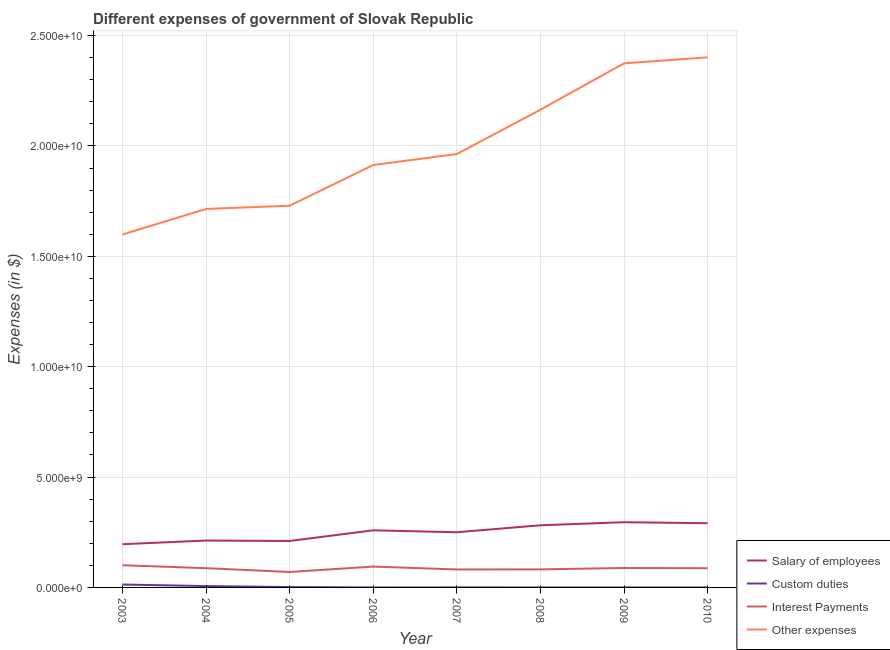How many different coloured lines are there?
Keep it short and to the point. 4. Does the line corresponding to amount spent on other expenses intersect with the line corresponding to amount spent on interest payments?
Make the answer very short. No. What is the amount spent on salary of employees in 2005?
Make the answer very short. 2.10e+09. Across all years, what is the maximum amount spent on salary of employees?
Provide a succinct answer. 2.96e+09. Across all years, what is the minimum amount spent on salary of employees?
Keep it short and to the point. 1.96e+09. In which year was the amount spent on interest payments maximum?
Your response must be concise. 2003. What is the total amount spent on interest payments in the graph?
Ensure brevity in your answer.  6.91e+09. What is the difference between the amount spent on custom duties in 2003 and that in 2010?
Keep it short and to the point. 1.31e+08. What is the difference between the amount spent on custom duties in 2006 and the amount spent on salary of employees in 2010?
Give a very brief answer. -2.91e+09. What is the average amount spent on interest payments per year?
Your response must be concise. 8.63e+08. In the year 2007, what is the difference between the amount spent on salary of employees and amount spent on other expenses?
Offer a terse response. -1.71e+1. What is the ratio of the amount spent on interest payments in 2005 to that in 2010?
Offer a terse response. 0.8. Is the amount spent on interest payments in 2004 less than that in 2006?
Keep it short and to the point. Yes. What is the difference between the highest and the second highest amount spent on custom duties?
Your answer should be very brief. 6.98e+07. What is the difference between the highest and the lowest amount spent on interest payments?
Offer a very short reply. 3.06e+08. In how many years, is the amount spent on other expenses greater than the average amount spent on other expenses taken over all years?
Offer a terse response. 3. Is it the case that in every year, the sum of the amount spent on other expenses and amount spent on salary of employees is greater than the sum of amount spent on custom duties and amount spent on interest payments?
Provide a short and direct response. Yes. Is it the case that in every year, the sum of the amount spent on salary of employees and amount spent on custom duties is greater than the amount spent on interest payments?
Provide a short and direct response. Yes. Is the amount spent on other expenses strictly greater than the amount spent on salary of employees over the years?
Your response must be concise. Yes. How many lines are there?
Offer a terse response. 4. How many years are there in the graph?
Offer a very short reply. 8. Are the values on the major ticks of Y-axis written in scientific E-notation?
Your response must be concise. Yes. Does the graph contain any zero values?
Offer a very short reply. Yes. Where does the legend appear in the graph?
Keep it short and to the point. Bottom right. How are the legend labels stacked?
Ensure brevity in your answer.  Vertical. What is the title of the graph?
Keep it short and to the point. Different expenses of government of Slovak Republic. Does "Denmark" appear as one of the legend labels in the graph?
Provide a short and direct response. No. What is the label or title of the X-axis?
Keep it short and to the point. Year. What is the label or title of the Y-axis?
Give a very brief answer. Expenses (in $). What is the Expenses (in $) of Salary of employees in 2003?
Your response must be concise. 1.96e+09. What is the Expenses (in $) of Custom duties in 2003?
Provide a short and direct response. 1.31e+08. What is the Expenses (in $) in Interest Payments in 2003?
Make the answer very short. 1.01e+09. What is the Expenses (in $) in Other expenses in 2003?
Provide a succinct answer. 1.60e+1. What is the Expenses (in $) of Salary of employees in 2004?
Offer a very short reply. 2.12e+09. What is the Expenses (in $) in Custom duties in 2004?
Ensure brevity in your answer.  6.16e+07. What is the Expenses (in $) in Interest Payments in 2004?
Ensure brevity in your answer.  8.73e+08. What is the Expenses (in $) in Other expenses in 2004?
Make the answer very short. 1.71e+1. What is the Expenses (in $) in Salary of employees in 2005?
Your answer should be compact. 2.10e+09. What is the Expenses (in $) of Custom duties in 2005?
Ensure brevity in your answer.  1.66e+07. What is the Expenses (in $) of Interest Payments in 2005?
Give a very brief answer. 7.00e+08. What is the Expenses (in $) of Other expenses in 2005?
Your answer should be compact. 1.73e+1. What is the Expenses (in $) in Salary of employees in 2006?
Your response must be concise. 2.59e+09. What is the Expenses (in $) of Custom duties in 2006?
Your response must be concise. 0. What is the Expenses (in $) in Interest Payments in 2006?
Keep it short and to the point. 9.45e+08. What is the Expenses (in $) of Other expenses in 2006?
Your response must be concise. 1.91e+1. What is the Expenses (in $) of Salary of employees in 2007?
Provide a succinct answer. 2.50e+09. What is the Expenses (in $) of Custom duties in 2007?
Your answer should be very brief. 7.16e+05. What is the Expenses (in $) of Interest Payments in 2007?
Your response must be concise. 8.14e+08. What is the Expenses (in $) in Other expenses in 2007?
Your answer should be very brief. 1.96e+1. What is the Expenses (in $) in Salary of employees in 2008?
Your answer should be very brief. 2.82e+09. What is the Expenses (in $) in Custom duties in 2008?
Your answer should be compact. 2.90e+04. What is the Expenses (in $) in Interest Payments in 2008?
Give a very brief answer. 8.18e+08. What is the Expenses (in $) of Other expenses in 2008?
Your answer should be very brief. 2.16e+1. What is the Expenses (in $) of Salary of employees in 2009?
Your answer should be compact. 2.96e+09. What is the Expenses (in $) in Custom duties in 2009?
Provide a succinct answer. 2.80e+04. What is the Expenses (in $) of Interest Payments in 2009?
Your answer should be very brief. 8.80e+08. What is the Expenses (in $) in Other expenses in 2009?
Your answer should be compact. 2.37e+1. What is the Expenses (in $) in Salary of employees in 2010?
Your answer should be compact. 2.91e+09. What is the Expenses (in $) in Custom duties in 2010?
Provide a succinct answer. 2.88e+04. What is the Expenses (in $) in Interest Payments in 2010?
Ensure brevity in your answer.  8.71e+08. What is the Expenses (in $) of Other expenses in 2010?
Give a very brief answer. 2.40e+1. Across all years, what is the maximum Expenses (in $) of Salary of employees?
Make the answer very short. 2.96e+09. Across all years, what is the maximum Expenses (in $) in Custom duties?
Offer a very short reply. 1.31e+08. Across all years, what is the maximum Expenses (in $) of Interest Payments?
Provide a short and direct response. 1.01e+09. Across all years, what is the maximum Expenses (in $) of Other expenses?
Your answer should be compact. 2.40e+1. Across all years, what is the minimum Expenses (in $) in Salary of employees?
Make the answer very short. 1.96e+09. Across all years, what is the minimum Expenses (in $) of Interest Payments?
Offer a terse response. 7.00e+08. Across all years, what is the minimum Expenses (in $) in Other expenses?
Provide a succinct answer. 1.60e+1. What is the total Expenses (in $) in Salary of employees in the graph?
Provide a succinct answer. 2.00e+1. What is the total Expenses (in $) of Custom duties in the graph?
Offer a very short reply. 2.10e+08. What is the total Expenses (in $) in Interest Payments in the graph?
Make the answer very short. 6.91e+09. What is the total Expenses (in $) in Other expenses in the graph?
Your answer should be very brief. 1.59e+11. What is the difference between the Expenses (in $) of Salary of employees in 2003 and that in 2004?
Provide a succinct answer. -1.66e+08. What is the difference between the Expenses (in $) of Custom duties in 2003 and that in 2004?
Offer a terse response. 6.98e+07. What is the difference between the Expenses (in $) of Interest Payments in 2003 and that in 2004?
Provide a succinct answer. 1.33e+08. What is the difference between the Expenses (in $) in Other expenses in 2003 and that in 2004?
Keep it short and to the point. -1.16e+09. What is the difference between the Expenses (in $) of Salary of employees in 2003 and that in 2005?
Your answer should be very brief. -1.46e+08. What is the difference between the Expenses (in $) of Custom duties in 2003 and that in 2005?
Your answer should be very brief. 1.15e+08. What is the difference between the Expenses (in $) in Interest Payments in 2003 and that in 2005?
Provide a short and direct response. 3.06e+08. What is the difference between the Expenses (in $) in Other expenses in 2003 and that in 2005?
Ensure brevity in your answer.  -1.31e+09. What is the difference between the Expenses (in $) of Salary of employees in 2003 and that in 2006?
Make the answer very short. -6.29e+08. What is the difference between the Expenses (in $) in Interest Payments in 2003 and that in 2006?
Ensure brevity in your answer.  6.08e+07. What is the difference between the Expenses (in $) in Other expenses in 2003 and that in 2006?
Your answer should be very brief. -3.15e+09. What is the difference between the Expenses (in $) in Salary of employees in 2003 and that in 2007?
Offer a terse response. -5.42e+08. What is the difference between the Expenses (in $) of Custom duties in 2003 and that in 2007?
Make the answer very short. 1.31e+08. What is the difference between the Expenses (in $) of Interest Payments in 2003 and that in 2007?
Give a very brief answer. 1.92e+08. What is the difference between the Expenses (in $) in Other expenses in 2003 and that in 2007?
Offer a very short reply. -3.65e+09. What is the difference between the Expenses (in $) in Salary of employees in 2003 and that in 2008?
Ensure brevity in your answer.  -8.58e+08. What is the difference between the Expenses (in $) in Custom duties in 2003 and that in 2008?
Offer a very short reply. 1.31e+08. What is the difference between the Expenses (in $) in Interest Payments in 2003 and that in 2008?
Your response must be concise. 1.88e+08. What is the difference between the Expenses (in $) in Other expenses in 2003 and that in 2008?
Provide a short and direct response. -5.65e+09. What is the difference between the Expenses (in $) of Salary of employees in 2003 and that in 2009?
Make the answer very short. -9.97e+08. What is the difference between the Expenses (in $) of Custom duties in 2003 and that in 2009?
Ensure brevity in your answer.  1.31e+08. What is the difference between the Expenses (in $) in Interest Payments in 2003 and that in 2009?
Make the answer very short. 1.26e+08. What is the difference between the Expenses (in $) in Other expenses in 2003 and that in 2009?
Provide a short and direct response. -7.75e+09. What is the difference between the Expenses (in $) in Salary of employees in 2003 and that in 2010?
Ensure brevity in your answer.  -9.51e+08. What is the difference between the Expenses (in $) in Custom duties in 2003 and that in 2010?
Provide a short and direct response. 1.31e+08. What is the difference between the Expenses (in $) of Interest Payments in 2003 and that in 2010?
Provide a short and direct response. 1.35e+08. What is the difference between the Expenses (in $) in Other expenses in 2003 and that in 2010?
Give a very brief answer. -8.03e+09. What is the difference between the Expenses (in $) in Salary of employees in 2004 and that in 2005?
Your answer should be very brief. 1.95e+07. What is the difference between the Expenses (in $) in Custom duties in 2004 and that in 2005?
Ensure brevity in your answer.  4.50e+07. What is the difference between the Expenses (in $) of Interest Payments in 2004 and that in 2005?
Make the answer very short. 1.73e+08. What is the difference between the Expenses (in $) in Other expenses in 2004 and that in 2005?
Give a very brief answer. -1.47e+08. What is the difference between the Expenses (in $) of Salary of employees in 2004 and that in 2006?
Ensure brevity in your answer.  -4.64e+08. What is the difference between the Expenses (in $) of Interest Payments in 2004 and that in 2006?
Provide a succinct answer. -7.22e+07. What is the difference between the Expenses (in $) of Other expenses in 2004 and that in 2006?
Offer a terse response. -1.99e+09. What is the difference between the Expenses (in $) in Salary of employees in 2004 and that in 2007?
Your answer should be compact. -3.76e+08. What is the difference between the Expenses (in $) of Custom duties in 2004 and that in 2007?
Provide a short and direct response. 6.09e+07. What is the difference between the Expenses (in $) of Interest Payments in 2004 and that in 2007?
Make the answer very short. 5.87e+07. What is the difference between the Expenses (in $) of Other expenses in 2004 and that in 2007?
Provide a short and direct response. -2.49e+09. What is the difference between the Expenses (in $) in Salary of employees in 2004 and that in 2008?
Your answer should be very brief. -6.92e+08. What is the difference between the Expenses (in $) in Custom duties in 2004 and that in 2008?
Give a very brief answer. 6.15e+07. What is the difference between the Expenses (in $) in Interest Payments in 2004 and that in 2008?
Provide a succinct answer. 5.47e+07. What is the difference between the Expenses (in $) in Other expenses in 2004 and that in 2008?
Offer a very short reply. -4.50e+09. What is the difference between the Expenses (in $) in Salary of employees in 2004 and that in 2009?
Make the answer very short. -8.31e+08. What is the difference between the Expenses (in $) of Custom duties in 2004 and that in 2009?
Offer a terse response. 6.15e+07. What is the difference between the Expenses (in $) in Interest Payments in 2004 and that in 2009?
Your answer should be compact. -7.40e+06. What is the difference between the Expenses (in $) of Other expenses in 2004 and that in 2009?
Offer a very short reply. -6.60e+09. What is the difference between the Expenses (in $) of Salary of employees in 2004 and that in 2010?
Offer a terse response. -7.85e+08. What is the difference between the Expenses (in $) of Custom duties in 2004 and that in 2010?
Your response must be concise. 6.15e+07. What is the difference between the Expenses (in $) in Interest Payments in 2004 and that in 2010?
Offer a terse response. 1.90e+06. What is the difference between the Expenses (in $) of Other expenses in 2004 and that in 2010?
Ensure brevity in your answer.  -6.87e+09. What is the difference between the Expenses (in $) in Salary of employees in 2005 and that in 2006?
Offer a very short reply. -4.83e+08. What is the difference between the Expenses (in $) in Interest Payments in 2005 and that in 2006?
Your response must be concise. -2.45e+08. What is the difference between the Expenses (in $) in Other expenses in 2005 and that in 2006?
Your answer should be compact. -1.84e+09. What is the difference between the Expenses (in $) of Salary of employees in 2005 and that in 2007?
Offer a terse response. -3.95e+08. What is the difference between the Expenses (in $) of Custom duties in 2005 and that in 2007?
Keep it short and to the point. 1.58e+07. What is the difference between the Expenses (in $) of Interest Payments in 2005 and that in 2007?
Offer a terse response. -1.14e+08. What is the difference between the Expenses (in $) in Other expenses in 2005 and that in 2007?
Ensure brevity in your answer.  -2.34e+09. What is the difference between the Expenses (in $) in Salary of employees in 2005 and that in 2008?
Give a very brief answer. -7.11e+08. What is the difference between the Expenses (in $) in Custom duties in 2005 and that in 2008?
Offer a terse response. 1.65e+07. What is the difference between the Expenses (in $) of Interest Payments in 2005 and that in 2008?
Keep it short and to the point. -1.18e+08. What is the difference between the Expenses (in $) of Other expenses in 2005 and that in 2008?
Make the answer very short. -4.35e+09. What is the difference between the Expenses (in $) in Salary of employees in 2005 and that in 2009?
Ensure brevity in your answer.  -8.51e+08. What is the difference between the Expenses (in $) in Custom duties in 2005 and that in 2009?
Give a very brief answer. 1.65e+07. What is the difference between the Expenses (in $) in Interest Payments in 2005 and that in 2009?
Your answer should be compact. -1.80e+08. What is the difference between the Expenses (in $) in Other expenses in 2005 and that in 2009?
Keep it short and to the point. -6.45e+09. What is the difference between the Expenses (in $) in Salary of employees in 2005 and that in 2010?
Your answer should be compact. -8.04e+08. What is the difference between the Expenses (in $) of Custom duties in 2005 and that in 2010?
Offer a terse response. 1.65e+07. What is the difference between the Expenses (in $) in Interest Payments in 2005 and that in 2010?
Provide a succinct answer. -1.71e+08. What is the difference between the Expenses (in $) in Other expenses in 2005 and that in 2010?
Make the answer very short. -6.72e+09. What is the difference between the Expenses (in $) of Salary of employees in 2006 and that in 2007?
Offer a terse response. 8.77e+07. What is the difference between the Expenses (in $) of Interest Payments in 2006 and that in 2007?
Your answer should be very brief. 1.31e+08. What is the difference between the Expenses (in $) in Other expenses in 2006 and that in 2007?
Keep it short and to the point. -4.96e+08. What is the difference between the Expenses (in $) of Salary of employees in 2006 and that in 2008?
Make the answer very short. -2.28e+08. What is the difference between the Expenses (in $) in Interest Payments in 2006 and that in 2008?
Give a very brief answer. 1.27e+08. What is the difference between the Expenses (in $) in Other expenses in 2006 and that in 2008?
Your response must be concise. -2.50e+09. What is the difference between the Expenses (in $) of Salary of employees in 2006 and that in 2009?
Make the answer very short. -3.68e+08. What is the difference between the Expenses (in $) in Interest Payments in 2006 and that in 2009?
Offer a terse response. 6.48e+07. What is the difference between the Expenses (in $) in Other expenses in 2006 and that in 2009?
Keep it short and to the point. -4.61e+09. What is the difference between the Expenses (in $) in Salary of employees in 2006 and that in 2010?
Provide a succinct answer. -3.21e+08. What is the difference between the Expenses (in $) of Interest Payments in 2006 and that in 2010?
Make the answer very short. 7.41e+07. What is the difference between the Expenses (in $) of Other expenses in 2006 and that in 2010?
Provide a succinct answer. -4.88e+09. What is the difference between the Expenses (in $) of Salary of employees in 2007 and that in 2008?
Offer a very short reply. -3.16e+08. What is the difference between the Expenses (in $) in Custom duties in 2007 and that in 2008?
Offer a very short reply. 6.87e+05. What is the difference between the Expenses (in $) in Interest Payments in 2007 and that in 2008?
Offer a very short reply. -4.01e+06. What is the difference between the Expenses (in $) in Other expenses in 2007 and that in 2008?
Your answer should be very brief. -2.01e+09. What is the difference between the Expenses (in $) in Salary of employees in 2007 and that in 2009?
Provide a succinct answer. -4.55e+08. What is the difference between the Expenses (in $) in Custom duties in 2007 and that in 2009?
Keep it short and to the point. 6.88e+05. What is the difference between the Expenses (in $) of Interest Payments in 2007 and that in 2009?
Give a very brief answer. -6.61e+07. What is the difference between the Expenses (in $) in Other expenses in 2007 and that in 2009?
Give a very brief answer. -4.11e+09. What is the difference between the Expenses (in $) in Salary of employees in 2007 and that in 2010?
Offer a very short reply. -4.09e+08. What is the difference between the Expenses (in $) in Custom duties in 2007 and that in 2010?
Ensure brevity in your answer.  6.87e+05. What is the difference between the Expenses (in $) of Interest Payments in 2007 and that in 2010?
Keep it short and to the point. -5.68e+07. What is the difference between the Expenses (in $) in Other expenses in 2007 and that in 2010?
Offer a very short reply. -4.38e+09. What is the difference between the Expenses (in $) of Salary of employees in 2008 and that in 2009?
Provide a succinct answer. -1.39e+08. What is the difference between the Expenses (in $) of Custom duties in 2008 and that in 2009?
Give a very brief answer. 996.89. What is the difference between the Expenses (in $) of Interest Payments in 2008 and that in 2009?
Make the answer very short. -6.21e+07. What is the difference between the Expenses (in $) in Other expenses in 2008 and that in 2009?
Your answer should be very brief. -2.10e+09. What is the difference between the Expenses (in $) in Salary of employees in 2008 and that in 2010?
Keep it short and to the point. -9.27e+07. What is the difference between the Expenses (in $) in Custom duties in 2008 and that in 2010?
Offer a very short reply. 207.07. What is the difference between the Expenses (in $) in Interest Payments in 2008 and that in 2010?
Offer a terse response. -5.28e+07. What is the difference between the Expenses (in $) in Other expenses in 2008 and that in 2010?
Ensure brevity in your answer.  -2.37e+09. What is the difference between the Expenses (in $) of Salary of employees in 2009 and that in 2010?
Keep it short and to the point. 4.65e+07. What is the difference between the Expenses (in $) of Custom duties in 2009 and that in 2010?
Provide a short and direct response. -789.82. What is the difference between the Expenses (in $) in Interest Payments in 2009 and that in 2010?
Your answer should be compact. 9.30e+06. What is the difference between the Expenses (in $) of Other expenses in 2009 and that in 2010?
Keep it short and to the point. -2.73e+08. What is the difference between the Expenses (in $) in Salary of employees in 2003 and the Expenses (in $) in Custom duties in 2004?
Offer a terse response. 1.90e+09. What is the difference between the Expenses (in $) of Salary of employees in 2003 and the Expenses (in $) of Interest Payments in 2004?
Your answer should be compact. 1.09e+09. What is the difference between the Expenses (in $) of Salary of employees in 2003 and the Expenses (in $) of Other expenses in 2004?
Your response must be concise. -1.52e+1. What is the difference between the Expenses (in $) of Custom duties in 2003 and the Expenses (in $) of Interest Payments in 2004?
Make the answer very short. -7.41e+08. What is the difference between the Expenses (in $) in Custom duties in 2003 and the Expenses (in $) in Other expenses in 2004?
Your answer should be very brief. -1.70e+1. What is the difference between the Expenses (in $) of Interest Payments in 2003 and the Expenses (in $) of Other expenses in 2004?
Your answer should be compact. -1.61e+1. What is the difference between the Expenses (in $) of Salary of employees in 2003 and the Expenses (in $) of Custom duties in 2005?
Ensure brevity in your answer.  1.94e+09. What is the difference between the Expenses (in $) in Salary of employees in 2003 and the Expenses (in $) in Interest Payments in 2005?
Offer a terse response. 1.26e+09. What is the difference between the Expenses (in $) in Salary of employees in 2003 and the Expenses (in $) in Other expenses in 2005?
Provide a short and direct response. -1.53e+1. What is the difference between the Expenses (in $) in Custom duties in 2003 and the Expenses (in $) in Interest Payments in 2005?
Make the answer very short. -5.69e+08. What is the difference between the Expenses (in $) of Custom duties in 2003 and the Expenses (in $) of Other expenses in 2005?
Offer a very short reply. -1.72e+1. What is the difference between the Expenses (in $) in Interest Payments in 2003 and the Expenses (in $) in Other expenses in 2005?
Offer a terse response. -1.63e+1. What is the difference between the Expenses (in $) in Salary of employees in 2003 and the Expenses (in $) in Interest Payments in 2006?
Offer a very short reply. 1.01e+09. What is the difference between the Expenses (in $) of Salary of employees in 2003 and the Expenses (in $) of Other expenses in 2006?
Keep it short and to the point. -1.72e+1. What is the difference between the Expenses (in $) in Custom duties in 2003 and the Expenses (in $) in Interest Payments in 2006?
Your answer should be very brief. -8.13e+08. What is the difference between the Expenses (in $) in Custom duties in 2003 and the Expenses (in $) in Other expenses in 2006?
Your response must be concise. -1.90e+1. What is the difference between the Expenses (in $) in Interest Payments in 2003 and the Expenses (in $) in Other expenses in 2006?
Your answer should be very brief. -1.81e+1. What is the difference between the Expenses (in $) of Salary of employees in 2003 and the Expenses (in $) of Custom duties in 2007?
Keep it short and to the point. 1.96e+09. What is the difference between the Expenses (in $) of Salary of employees in 2003 and the Expenses (in $) of Interest Payments in 2007?
Offer a very short reply. 1.14e+09. What is the difference between the Expenses (in $) in Salary of employees in 2003 and the Expenses (in $) in Other expenses in 2007?
Your answer should be very brief. -1.77e+1. What is the difference between the Expenses (in $) of Custom duties in 2003 and the Expenses (in $) of Interest Payments in 2007?
Your answer should be very brief. -6.83e+08. What is the difference between the Expenses (in $) in Custom duties in 2003 and the Expenses (in $) in Other expenses in 2007?
Keep it short and to the point. -1.95e+1. What is the difference between the Expenses (in $) of Interest Payments in 2003 and the Expenses (in $) of Other expenses in 2007?
Provide a short and direct response. -1.86e+1. What is the difference between the Expenses (in $) in Salary of employees in 2003 and the Expenses (in $) in Custom duties in 2008?
Your response must be concise. 1.96e+09. What is the difference between the Expenses (in $) in Salary of employees in 2003 and the Expenses (in $) in Interest Payments in 2008?
Keep it short and to the point. 1.14e+09. What is the difference between the Expenses (in $) in Salary of employees in 2003 and the Expenses (in $) in Other expenses in 2008?
Make the answer very short. -1.97e+1. What is the difference between the Expenses (in $) in Custom duties in 2003 and the Expenses (in $) in Interest Payments in 2008?
Provide a short and direct response. -6.87e+08. What is the difference between the Expenses (in $) of Custom duties in 2003 and the Expenses (in $) of Other expenses in 2008?
Provide a succinct answer. -2.15e+1. What is the difference between the Expenses (in $) in Interest Payments in 2003 and the Expenses (in $) in Other expenses in 2008?
Keep it short and to the point. -2.06e+1. What is the difference between the Expenses (in $) of Salary of employees in 2003 and the Expenses (in $) of Custom duties in 2009?
Your response must be concise. 1.96e+09. What is the difference between the Expenses (in $) in Salary of employees in 2003 and the Expenses (in $) in Interest Payments in 2009?
Make the answer very short. 1.08e+09. What is the difference between the Expenses (in $) in Salary of employees in 2003 and the Expenses (in $) in Other expenses in 2009?
Keep it short and to the point. -2.18e+1. What is the difference between the Expenses (in $) in Custom duties in 2003 and the Expenses (in $) in Interest Payments in 2009?
Offer a very short reply. -7.49e+08. What is the difference between the Expenses (in $) of Custom duties in 2003 and the Expenses (in $) of Other expenses in 2009?
Ensure brevity in your answer.  -2.36e+1. What is the difference between the Expenses (in $) of Interest Payments in 2003 and the Expenses (in $) of Other expenses in 2009?
Make the answer very short. -2.27e+1. What is the difference between the Expenses (in $) of Salary of employees in 2003 and the Expenses (in $) of Custom duties in 2010?
Provide a short and direct response. 1.96e+09. What is the difference between the Expenses (in $) of Salary of employees in 2003 and the Expenses (in $) of Interest Payments in 2010?
Your answer should be very brief. 1.09e+09. What is the difference between the Expenses (in $) of Salary of employees in 2003 and the Expenses (in $) of Other expenses in 2010?
Offer a very short reply. -2.21e+1. What is the difference between the Expenses (in $) of Custom duties in 2003 and the Expenses (in $) of Interest Payments in 2010?
Offer a very short reply. -7.39e+08. What is the difference between the Expenses (in $) of Custom duties in 2003 and the Expenses (in $) of Other expenses in 2010?
Your answer should be compact. -2.39e+1. What is the difference between the Expenses (in $) of Interest Payments in 2003 and the Expenses (in $) of Other expenses in 2010?
Keep it short and to the point. -2.30e+1. What is the difference between the Expenses (in $) in Salary of employees in 2004 and the Expenses (in $) in Custom duties in 2005?
Keep it short and to the point. 2.11e+09. What is the difference between the Expenses (in $) in Salary of employees in 2004 and the Expenses (in $) in Interest Payments in 2005?
Offer a terse response. 1.42e+09. What is the difference between the Expenses (in $) in Salary of employees in 2004 and the Expenses (in $) in Other expenses in 2005?
Provide a succinct answer. -1.52e+1. What is the difference between the Expenses (in $) of Custom duties in 2004 and the Expenses (in $) of Interest Payments in 2005?
Offer a terse response. -6.38e+08. What is the difference between the Expenses (in $) in Custom duties in 2004 and the Expenses (in $) in Other expenses in 2005?
Keep it short and to the point. -1.72e+1. What is the difference between the Expenses (in $) in Interest Payments in 2004 and the Expenses (in $) in Other expenses in 2005?
Your answer should be very brief. -1.64e+1. What is the difference between the Expenses (in $) of Salary of employees in 2004 and the Expenses (in $) of Interest Payments in 2006?
Provide a short and direct response. 1.18e+09. What is the difference between the Expenses (in $) in Salary of employees in 2004 and the Expenses (in $) in Other expenses in 2006?
Give a very brief answer. -1.70e+1. What is the difference between the Expenses (in $) in Custom duties in 2004 and the Expenses (in $) in Interest Payments in 2006?
Provide a short and direct response. -8.83e+08. What is the difference between the Expenses (in $) in Custom duties in 2004 and the Expenses (in $) in Other expenses in 2006?
Offer a terse response. -1.91e+1. What is the difference between the Expenses (in $) in Interest Payments in 2004 and the Expenses (in $) in Other expenses in 2006?
Provide a succinct answer. -1.83e+1. What is the difference between the Expenses (in $) in Salary of employees in 2004 and the Expenses (in $) in Custom duties in 2007?
Your answer should be very brief. 2.12e+09. What is the difference between the Expenses (in $) of Salary of employees in 2004 and the Expenses (in $) of Interest Payments in 2007?
Offer a very short reply. 1.31e+09. What is the difference between the Expenses (in $) of Salary of employees in 2004 and the Expenses (in $) of Other expenses in 2007?
Ensure brevity in your answer.  -1.75e+1. What is the difference between the Expenses (in $) of Custom duties in 2004 and the Expenses (in $) of Interest Payments in 2007?
Keep it short and to the point. -7.52e+08. What is the difference between the Expenses (in $) in Custom duties in 2004 and the Expenses (in $) in Other expenses in 2007?
Offer a very short reply. -1.96e+1. What is the difference between the Expenses (in $) in Interest Payments in 2004 and the Expenses (in $) in Other expenses in 2007?
Your response must be concise. -1.88e+1. What is the difference between the Expenses (in $) in Salary of employees in 2004 and the Expenses (in $) in Custom duties in 2008?
Offer a very short reply. 2.12e+09. What is the difference between the Expenses (in $) in Salary of employees in 2004 and the Expenses (in $) in Interest Payments in 2008?
Provide a short and direct response. 1.31e+09. What is the difference between the Expenses (in $) of Salary of employees in 2004 and the Expenses (in $) of Other expenses in 2008?
Give a very brief answer. -1.95e+1. What is the difference between the Expenses (in $) of Custom duties in 2004 and the Expenses (in $) of Interest Payments in 2008?
Your response must be concise. -7.56e+08. What is the difference between the Expenses (in $) of Custom duties in 2004 and the Expenses (in $) of Other expenses in 2008?
Offer a very short reply. -2.16e+1. What is the difference between the Expenses (in $) in Interest Payments in 2004 and the Expenses (in $) in Other expenses in 2008?
Offer a terse response. -2.08e+1. What is the difference between the Expenses (in $) of Salary of employees in 2004 and the Expenses (in $) of Custom duties in 2009?
Provide a short and direct response. 2.12e+09. What is the difference between the Expenses (in $) of Salary of employees in 2004 and the Expenses (in $) of Interest Payments in 2009?
Your answer should be compact. 1.24e+09. What is the difference between the Expenses (in $) of Salary of employees in 2004 and the Expenses (in $) of Other expenses in 2009?
Your response must be concise. -2.16e+1. What is the difference between the Expenses (in $) of Custom duties in 2004 and the Expenses (in $) of Interest Payments in 2009?
Your answer should be very brief. -8.18e+08. What is the difference between the Expenses (in $) of Custom duties in 2004 and the Expenses (in $) of Other expenses in 2009?
Give a very brief answer. -2.37e+1. What is the difference between the Expenses (in $) in Interest Payments in 2004 and the Expenses (in $) in Other expenses in 2009?
Provide a short and direct response. -2.29e+1. What is the difference between the Expenses (in $) of Salary of employees in 2004 and the Expenses (in $) of Custom duties in 2010?
Offer a terse response. 2.12e+09. What is the difference between the Expenses (in $) of Salary of employees in 2004 and the Expenses (in $) of Interest Payments in 2010?
Provide a short and direct response. 1.25e+09. What is the difference between the Expenses (in $) of Salary of employees in 2004 and the Expenses (in $) of Other expenses in 2010?
Your response must be concise. -2.19e+1. What is the difference between the Expenses (in $) of Custom duties in 2004 and the Expenses (in $) of Interest Payments in 2010?
Your answer should be very brief. -8.09e+08. What is the difference between the Expenses (in $) of Custom duties in 2004 and the Expenses (in $) of Other expenses in 2010?
Make the answer very short. -2.40e+1. What is the difference between the Expenses (in $) of Interest Payments in 2004 and the Expenses (in $) of Other expenses in 2010?
Offer a very short reply. -2.31e+1. What is the difference between the Expenses (in $) in Salary of employees in 2005 and the Expenses (in $) in Interest Payments in 2006?
Ensure brevity in your answer.  1.16e+09. What is the difference between the Expenses (in $) of Salary of employees in 2005 and the Expenses (in $) of Other expenses in 2006?
Your response must be concise. -1.70e+1. What is the difference between the Expenses (in $) of Custom duties in 2005 and the Expenses (in $) of Interest Payments in 2006?
Your answer should be very brief. -9.28e+08. What is the difference between the Expenses (in $) in Custom duties in 2005 and the Expenses (in $) in Other expenses in 2006?
Make the answer very short. -1.91e+1. What is the difference between the Expenses (in $) in Interest Payments in 2005 and the Expenses (in $) in Other expenses in 2006?
Ensure brevity in your answer.  -1.84e+1. What is the difference between the Expenses (in $) of Salary of employees in 2005 and the Expenses (in $) of Custom duties in 2007?
Provide a succinct answer. 2.10e+09. What is the difference between the Expenses (in $) in Salary of employees in 2005 and the Expenses (in $) in Interest Payments in 2007?
Offer a very short reply. 1.29e+09. What is the difference between the Expenses (in $) in Salary of employees in 2005 and the Expenses (in $) in Other expenses in 2007?
Your answer should be compact. -1.75e+1. What is the difference between the Expenses (in $) of Custom duties in 2005 and the Expenses (in $) of Interest Payments in 2007?
Keep it short and to the point. -7.97e+08. What is the difference between the Expenses (in $) in Custom duties in 2005 and the Expenses (in $) in Other expenses in 2007?
Ensure brevity in your answer.  -1.96e+1. What is the difference between the Expenses (in $) in Interest Payments in 2005 and the Expenses (in $) in Other expenses in 2007?
Your answer should be very brief. -1.89e+1. What is the difference between the Expenses (in $) of Salary of employees in 2005 and the Expenses (in $) of Custom duties in 2008?
Keep it short and to the point. 2.10e+09. What is the difference between the Expenses (in $) in Salary of employees in 2005 and the Expenses (in $) in Interest Payments in 2008?
Your answer should be very brief. 1.29e+09. What is the difference between the Expenses (in $) in Salary of employees in 2005 and the Expenses (in $) in Other expenses in 2008?
Offer a terse response. -1.95e+1. What is the difference between the Expenses (in $) of Custom duties in 2005 and the Expenses (in $) of Interest Payments in 2008?
Make the answer very short. -8.01e+08. What is the difference between the Expenses (in $) in Custom duties in 2005 and the Expenses (in $) in Other expenses in 2008?
Your answer should be very brief. -2.16e+1. What is the difference between the Expenses (in $) in Interest Payments in 2005 and the Expenses (in $) in Other expenses in 2008?
Ensure brevity in your answer.  -2.09e+1. What is the difference between the Expenses (in $) in Salary of employees in 2005 and the Expenses (in $) in Custom duties in 2009?
Offer a terse response. 2.10e+09. What is the difference between the Expenses (in $) of Salary of employees in 2005 and the Expenses (in $) of Interest Payments in 2009?
Keep it short and to the point. 1.22e+09. What is the difference between the Expenses (in $) of Salary of employees in 2005 and the Expenses (in $) of Other expenses in 2009?
Give a very brief answer. -2.16e+1. What is the difference between the Expenses (in $) of Custom duties in 2005 and the Expenses (in $) of Interest Payments in 2009?
Give a very brief answer. -8.64e+08. What is the difference between the Expenses (in $) in Custom duties in 2005 and the Expenses (in $) in Other expenses in 2009?
Provide a succinct answer. -2.37e+1. What is the difference between the Expenses (in $) in Interest Payments in 2005 and the Expenses (in $) in Other expenses in 2009?
Your answer should be compact. -2.30e+1. What is the difference between the Expenses (in $) of Salary of employees in 2005 and the Expenses (in $) of Custom duties in 2010?
Provide a short and direct response. 2.10e+09. What is the difference between the Expenses (in $) of Salary of employees in 2005 and the Expenses (in $) of Interest Payments in 2010?
Your answer should be compact. 1.23e+09. What is the difference between the Expenses (in $) of Salary of employees in 2005 and the Expenses (in $) of Other expenses in 2010?
Provide a succinct answer. -2.19e+1. What is the difference between the Expenses (in $) of Custom duties in 2005 and the Expenses (in $) of Interest Payments in 2010?
Keep it short and to the point. -8.54e+08. What is the difference between the Expenses (in $) in Custom duties in 2005 and the Expenses (in $) in Other expenses in 2010?
Your response must be concise. -2.40e+1. What is the difference between the Expenses (in $) of Interest Payments in 2005 and the Expenses (in $) of Other expenses in 2010?
Offer a very short reply. -2.33e+1. What is the difference between the Expenses (in $) of Salary of employees in 2006 and the Expenses (in $) of Custom duties in 2007?
Make the answer very short. 2.59e+09. What is the difference between the Expenses (in $) of Salary of employees in 2006 and the Expenses (in $) of Interest Payments in 2007?
Your answer should be compact. 1.77e+09. What is the difference between the Expenses (in $) of Salary of employees in 2006 and the Expenses (in $) of Other expenses in 2007?
Ensure brevity in your answer.  -1.70e+1. What is the difference between the Expenses (in $) of Interest Payments in 2006 and the Expenses (in $) of Other expenses in 2007?
Make the answer very short. -1.87e+1. What is the difference between the Expenses (in $) in Salary of employees in 2006 and the Expenses (in $) in Custom duties in 2008?
Your response must be concise. 2.59e+09. What is the difference between the Expenses (in $) of Salary of employees in 2006 and the Expenses (in $) of Interest Payments in 2008?
Your response must be concise. 1.77e+09. What is the difference between the Expenses (in $) of Salary of employees in 2006 and the Expenses (in $) of Other expenses in 2008?
Offer a very short reply. -1.91e+1. What is the difference between the Expenses (in $) in Interest Payments in 2006 and the Expenses (in $) in Other expenses in 2008?
Your answer should be very brief. -2.07e+1. What is the difference between the Expenses (in $) in Salary of employees in 2006 and the Expenses (in $) in Custom duties in 2009?
Ensure brevity in your answer.  2.59e+09. What is the difference between the Expenses (in $) in Salary of employees in 2006 and the Expenses (in $) in Interest Payments in 2009?
Your answer should be compact. 1.71e+09. What is the difference between the Expenses (in $) in Salary of employees in 2006 and the Expenses (in $) in Other expenses in 2009?
Your answer should be very brief. -2.12e+1. What is the difference between the Expenses (in $) in Interest Payments in 2006 and the Expenses (in $) in Other expenses in 2009?
Make the answer very short. -2.28e+1. What is the difference between the Expenses (in $) in Salary of employees in 2006 and the Expenses (in $) in Custom duties in 2010?
Keep it short and to the point. 2.59e+09. What is the difference between the Expenses (in $) in Salary of employees in 2006 and the Expenses (in $) in Interest Payments in 2010?
Ensure brevity in your answer.  1.72e+09. What is the difference between the Expenses (in $) in Salary of employees in 2006 and the Expenses (in $) in Other expenses in 2010?
Make the answer very short. -2.14e+1. What is the difference between the Expenses (in $) of Interest Payments in 2006 and the Expenses (in $) of Other expenses in 2010?
Ensure brevity in your answer.  -2.31e+1. What is the difference between the Expenses (in $) in Salary of employees in 2007 and the Expenses (in $) in Custom duties in 2008?
Your response must be concise. 2.50e+09. What is the difference between the Expenses (in $) of Salary of employees in 2007 and the Expenses (in $) of Interest Payments in 2008?
Give a very brief answer. 1.68e+09. What is the difference between the Expenses (in $) in Salary of employees in 2007 and the Expenses (in $) in Other expenses in 2008?
Ensure brevity in your answer.  -1.91e+1. What is the difference between the Expenses (in $) of Custom duties in 2007 and the Expenses (in $) of Interest Payments in 2008?
Give a very brief answer. -8.17e+08. What is the difference between the Expenses (in $) in Custom duties in 2007 and the Expenses (in $) in Other expenses in 2008?
Your response must be concise. -2.16e+1. What is the difference between the Expenses (in $) of Interest Payments in 2007 and the Expenses (in $) of Other expenses in 2008?
Provide a succinct answer. -2.08e+1. What is the difference between the Expenses (in $) in Salary of employees in 2007 and the Expenses (in $) in Custom duties in 2009?
Ensure brevity in your answer.  2.50e+09. What is the difference between the Expenses (in $) in Salary of employees in 2007 and the Expenses (in $) in Interest Payments in 2009?
Offer a terse response. 1.62e+09. What is the difference between the Expenses (in $) of Salary of employees in 2007 and the Expenses (in $) of Other expenses in 2009?
Provide a short and direct response. -2.12e+1. What is the difference between the Expenses (in $) in Custom duties in 2007 and the Expenses (in $) in Interest Payments in 2009?
Offer a terse response. -8.79e+08. What is the difference between the Expenses (in $) of Custom duties in 2007 and the Expenses (in $) of Other expenses in 2009?
Give a very brief answer. -2.37e+1. What is the difference between the Expenses (in $) in Interest Payments in 2007 and the Expenses (in $) in Other expenses in 2009?
Offer a terse response. -2.29e+1. What is the difference between the Expenses (in $) in Salary of employees in 2007 and the Expenses (in $) in Custom duties in 2010?
Your response must be concise. 2.50e+09. What is the difference between the Expenses (in $) of Salary of employees in 2007 and the Expenses (in $) of Interest Payments in 2010?
Keep it short and to the point. 1.63e+09. What is the difference between the Expenses (in $) in Salary of employees in 2007 and the Expenses (in $) in Other expenses in 2010?
Your answer should be very brief. -2.15e+1. What is the difference between the Expenses (in $) in Custom duties in 2007 and the Expenses (in $) in Interest Payments in 2010?
Make the answer very short. -8.70e+08. What is the difference between the Expenses (in $) of Custom duties in 2007 and the Expenses (in $) of Other expenses in 2010?
Provide a succinct answer. -2.40e+1. What is the difference between the Expenses (in $) of Interest Payments in 2007 and the Expenses (in $) of Other expenses in 2010?
Make the answer very short. -2.32e+1. What is the difference between the Expenses (in $) of Salary of employees in 2008 and the Expenses (in $) of Custom duties in 2009?
Provide a succinct answer. 2.82e+09. What is the difference between the Expenses (in $) of Salary of employees in 2008 and the Expenses (in $) of Interest Payments in 2009?
Provide a short and direct response. 1.94e+09. What is the difference between the Expenses (in $) in Salary of employees in 2008 and the Expenses (in $) in Other expenses in 2009?
Keep it short and to the point. -2.09e+1. What is the difference between the Expenses (in $) of Custom duties in 2008 and the Expenses (in $) of Interest Payments in 2009?
Your response must be concise. -8.80e+08. What is the difference between the Expenses (in $) of Custom duties in 2008 and the Expenses (in $) of Other expenses in 2009?
Keep it short and to the point. -2.37e+1. What is the difference between the Expenses (in $) of Interest Payments in 2008 and the Expenses (in $) of Other expenses in 2009?
Give a very brief answer. -2.29e+1. What is the difference between the Expenses (in $) in Salary of employees in 2008 and the Expenses (in $) in Custom duties in 2010?
Ensure brevity in your answer.  2.82e+09. What is the difference between the Expenses (in $) of Salary of employees in 2008 and the Expenses (in $) of Interest Payments in 2010?
Offer a terse response. 1.95e+09. What is the difference between the Expenses (in $) of Salary of employees in 2008 and the Expenses (in $) of Other expenses in 2010?
Provide a succinct answer. -2.12e+1. What is the difference between the Expenses (in $) of Custom duties in 2008 and the Expenses (in $) of Interest Payments in 2010?
Give a very brief answer. -8.71e+08. What is the difference between the Expenses (in $) in Custom duties in 2008 and the Expenses (in $) in Other expenses in 2010?
Keep it short and to the point. -2.40e+1. What is the difference between the Expenses (in $) in Interest Payments in 2008 and the Expenses (in $) in Other expenses in 2010?
Your answer should be very brief. -2.32e+1. What is the difference between the Expenses (in $) in Salary of employees in 2009 and the Expenses (in $) in Custom duties in 2010?
Provide a succinct answer. 2.96e+09. What is the difference between the Expenses (in $) of Salary of employees in 2009 and the Expenses (in $) of Interest Payments in 2010?
Keep it short and to the point. 2.08e+09. What is the difference between the Expenses (in $) of Salary of employees in 2009 and the Expenses (in $) of Other expenses in 2010?
Make the answer very short. -2.11e+1. What is the difference between the Expenses (in $) in Custom duties in 2009 and the Expenses (in $) in Interest Payments in 2010?
Your response must be concise. -8.71e+08. What is the difference between the Expenses (in $) in Custom duties in 2009 and the Expenses (in $) in Other expenses in 2010?
Your answer should be very brief. -2.40e+1. What is the difference between the Expenses (in $) in Interest Payments in 2009 and the Expenses (in $) in Other expenses in 2010?
Keep it short and to the point. -2.31e+1. What is the average Expenses (in $) of Salary of employees per year?
Make the answer very short. 2.49e+09. What is the average Expenses (in $) of Custom duties per year?
Your response must be concise. 2.63e+07. What is the average Expenses (in $) of Interest Payments per year?
Make the answer very short. 8.63e+08. What is the average Expenses (in $) in Other expenses per year?
Offer a terse response. 1.98e+1. In the year 2003, what is the difference between the Expenses (in $) of Salary of employees and Expenses (in $) of Custom duties?
Your answer should be compact. 1.83e+09. In the year 2003, what is the difference between the Expenses (in $) of Salary of employees and Expenses (in $) of Interest Payments?
Make the answer very short. 9.52e+08. In the year 2003, what is the difference between the Expenses (in $) of Salary of employees and Expenses (in $) of Other expenses?
Your answer should be compact. -1.40e+1. In the year 2003, what is the difference between the Expenses (in $) of Custom duties and Expenses (in $) of Interest Payments?
Ensure brevity in your answer.  -8.74e+08. In the year 2003, what is the difference between the Expenses (in $) in Custom duties and Expenses (in $) in Other expenses?
Provide a short and direct response. -1.59e+1. In the year 2003, what is the difference between the Expenses (in $) in Interest Payments and Expenses (in $) in Other expenses?
Give a very brief answer. -1.50e+1. In the year 2004, what is the difference between the Expenses (in $) in Salary of employees and Expenses (in $) in Custom duties?
Your answer should be compact. 2.06e+09. In the year 2004, what is the difference between the Expenses (in $) in Salary of employees and Expenses (in $) in Interest Payments?
Provide a short and direct response. 1.25e+09. In the year 2004, what is the difference between the Expenses (in $) of Salary of employees and Expenses (in $) of Other expenses?
Keep it short and to the point. -1.50e+1. In the year 2004, what is the difference between the Expenses (in $) of Custom duties and Expenses (in $) of Interest Payments?
Your response must be concise. -8.11e+08. In the year 2004, what is the difference between the Expenses (in $) in Custom duties and Expenses (in $) in Other expenses?
Keep it short and to the point. -1.71e+1. In the year 2004, what is the difference between the Expenses (in $) of Interest Payments and Expenses (in $) of Other expenses?
Your response must be concise. -1.63e+1. In the year 2005, what is the difference between the Expenses (in $) in Salary of employees and Expenses (in $) in Custom duties?
Offer a very short reply. 2.09e+09. In the year 2005, what is the difference between the Expenses (in $) in Salary of employees and Expenses (in $) in Interest Payments?
Offer a very short reply. 1.40e+09. In the year 2005, what is the difference between the Expenses (in $) in Salary of employees and Expenses (in $) in Other expenses?
Offer a very short reply. -1.52e+1. In the year 2005, what is the difference between the Expenses (in $) in Custom duties and Expenses (in $) in Interest Payments?
Your response must be concise. -6.83e+08. In the year 2005, what is the difference between the Expenses (in $) in Custom duties and Expenses (in $) in Other expenses?
Your response must be concise. -1.73e+1. In the year 2005, what is the difference between the Expenses (in $) in Interest Payments and Expenses (in $) in Other expenses?
Your answer should be very brief. -1.66e+1. In the year 2006, what is the difference between the Expenses (in $) of Salary of employees and Expenses (in $) of Interest Payments?
Provide a succinct answer. 1.64e+09. In the year 2006, what is the difference between the Expenses (in $) in Salary of employees and Expenses (in $) in Other expenses?
Give a very brief answer. -1.66e+1. In the year 2006, what is the difference between the Expenses (in $) of Interest Payments and Expenses (in $) of Other expenses?
Your answer should be compact. -1.82e+1. In the year 2007, what is the difference between the Expenses (in $) of Salary of employees and Expenses (in $) of Custom duties?
Offer a very short reply. 2.50e+09. In the year 2007, what is the difference between the Expenses (in $) in Salary of employees and Expenses (in $) in Interest Payments?
Keep it short and to the point. 1.69e+09. In the year 2007, what is the difference between the Expenses (in $) of Salary of employees and Expenses (in $) of Other expenses?
Make the answer very short. -1.71e+1. In the year 2007, what is the difference between the Expenses (in $) in Custom duties and Expenses (in $) in Interest Payments?
Give a very brief answer. -8.13e+08. In the year 2007, what is the difference between the Expenses (in $) of Custom duties and Expenses (in $) of Other expenses?
Offer a terse response. -1.96e+1. In the year 2007, what is the difference between the Expenses (in $) of Interest Payments and Expenses (in $) of Other expenses?
Give a very brief answer. -1.88e+1. In the year 2008, what is the difference between the Expenses (in $) in Salary of employees and Expenses (in $) in Custom duties?
Your response must be concise. 2.82e+09. In the year 2008, what is the difference between the Expenses (in $) in Salary of employees and Expenses (in $) in Interest Payments?
Provide a succinct answer. 2.00e+09. In the year 2008, what is the difference between the Expenses (in $) of Salary of employees and Expenses (in $) of Other expenses?
Your response must be concise. -1.88e+1. In the year 2008, what is the difference between the Expenses (in $) in Custom duties and Expenses (in $) in Interest Payments?
Make the answer very short. -8.18e+08. In the year 2008, what is the difference between the Expenses (in $) of Custom duties and Expenses (in $) of Other expenses?
Your answer should be very brief. -2.16e+1. In the year 2008, what is the difference between the Expenses (in $) in Interest Payments and Expenses (in $) in Other expenses?
Provide a succinct answer. -2.08e+1. In the year 2009, what is the difference between the Expenses (in $) in Salary of employees and Expenses (in $) in Custom duties?
Your answer should be compact. 2.96e+09. In the year 2009, what is the difference between the Expenses (in $) in Salary of employees and Expenses (in $) in Interest Payments?
Provide a short and direct response. 2.07e+09. In the year 2009, what is the difference between the Expenses (in $) in Salary of employees and Expenses (in $) in Other expenses?
Make the answer very short. -2.08e+1. In the year 2009, what is the difference between the Expenses (in $) in Custom duties and Expenses (in $) in Interest Payments?
Your response must be concise. -8.80e+08. In the year 2009, what is the difference between the Expenses (in $) of Custom duties and Expenses (in $) of Other expenses?
Provide a short and direct response. -2.37e+1. In the year 2009, what is the difference between the Expenses (in $) in Interest Payments and Expenses (in $) in Other expenses?
Your response must be concise. -2.29e+1. In the year 2010, what is the difference between the Expenses (in $) of Salary of employees and Expenses (in $) of Custom duties?
Provide a succinct answer. 2.91e+09. In the year 2010, what is the difference between the Expenses (in $) in Salary of employees and Expenses (in $) in Interest Payments?
Offer a terse response. 2.04e+09. In the year 2010, what is the difference between the Expenses (in $) in Salary of employees and Expenses (in $) in Other expenses?
Give a very brief answer. -2.11e+1. In the year 2010, what is the difference between the Expenses (in $) in Custom duties and Expenses (in $) in Interest Payments?
Provide a succinct answer. -8.71e+08. In the year 2010, what is the difference between the Expenses (in $) of Custom duties and Expenses (in $) of Other expenses?
Offer a terse response. -2.40e+1. In the year 2010, what is the difference between the Expenses (in $) of Interest Payments and Expenses (in $) of Other expenses?
Offer a terse response. -2.31e+1. What is the ratio of the Expenses (in $) in Salary of employees in 2003 to that in 2004?
Ensure brevity in your answer.  0.92. What is the ratio of the Expenses (in $) of Custom duties in 2003 to that in 2004?
Offer a terse response. 2.13. What is the ratio of the Expenses (in $) in Interest Payments in 2003 to that in 2004?
Give a very brief answer. 1.15. What is the ratio of the Expenses (in $) of Other expenses in 2003 to that in 2004?
Your answer should be very brief. 0.93. What is the ratio of the Expenses (in $) in Salary of employees in 2003 to that in 2005?
Your response must be concise. 0.93. What is the ratio of the Expenses (in $) of Custom duties in 2003 to that in 2005?
Your answer should be compact. 7.93. What is the ratio of the Expenses (in $) of Interest Payments in 2003 to that in 2005?
Your answer should be very brief. 1.44. What is the ratio of the Expenses (in $) in Other expenses in 2003 to that in 2005?
Give a very brief answer. 0.92. What is the ratio of the Expenses (in $) of Salary of employees in 2003 to that in 2006?
Your response must be concise. 0.76. What is the ratio of the Expenses (in $) in Interest Payments in 2003 to that in 2006?
Offer a very short reply. 1.06. What is the ratio of the Expenses (in $) in Other expenses in 2003 to that in 2006?
Your response must be concise. 0.84. What is the ratio of the Expenses (in $) of Salary of employees in 2003 to that in 2007?
Offer a very short reply. 0.78. What is the ratio of the Expenses (in $) of Custom duties in 2003 to that in 2007?
Make the answer very short. 183.51. What is the ratio of the Expenses (in $) in Interest Payments in 2003 to that in 2007?
Your answer should be compact. 1.24. What is the ratio of the Expenses (in $) of Other expenses in 2003 to that in 2007?
Keep it short and to the point. 0.81. What is the ratio of the Expenses (in $) in Salary of employees in 2003 to that in 2008?
Your answer should be very brief. 0.7. What is the ratio of the Expenses (in $) in Custom duties in 2003 to that in 2008?
Your response must be concise. 4530.46. What is the ratio of the Expenses (in $) in Interest Payments in 2003 to that in 2008?
Offer a very short reply. 1.23. What is the ratio of the Expenses (in $) of Other expenses in 2003 to that in 2008?
Make the answer very short. 0.74. What is the ratio of the Expenses (in $) in Salary of employees in 2003 to that in 2009?
Provide a short and direct response. 0.66. What is the ratio of the Expenses (in $) of Custom duties in 2003 to that in 2009?
Your answer should be very brief. 4691.7. What is the ratio of the Expenses (in $) of Interest Payments in 2003 to that in 2009?
Give a very brief answer. 1.14. What is the ratio of the Expenses (in $) in Other expenses in 2003 to that in 2009?
Give a very brief answer. 0.67. What is the ratio of the Expenses (in $) in Salary of employees in 2003 to that in 2010?
Provide a short and direct response. 0.67. What is the ratio of the Expenses (in $) of Custom duties in 2003 to that in 2010?
Your answer should be very brief. 4563.03. What is the ratio of the Expenses (in $) in Interest Payments in 2003 to that in 2010?
Your answer should be very brief. 1.15. What is the ratio of the Expenses (in $) in Other expenses in 2003 to that in 2010?
Provide a succinct answer. 0.67. What is the ratio of the Expenses (in $) in Salary of employees in 2004 to that in 2005?
Offer a terse response. 1.01. What is the ratio of the Expenses (in $) in Custom duties in 2004 to that in 2005?
Ensure brevity in your answer.  3.72. What is the ratio of the Expenses (in $) of Interest Payments in 2004 to that in 2005?
Provide a short and direct response. 1.25. What is the ratio of the Expenses (in $) in Salary of employees in 2004 to that in 2006?
Make the answer very short. 0.82. What is the ratio of the Expenses (in $) of Interest Payments in 2004 to that in 2006?
Provide a succinct answer. 0.92. What is the ratio of the Expenses (in $) of Other expenses in 2004 to that in 2006?
Your answer should be very brief. 0.9. What is the ratio of the Expenses (in $) of Salary of employees in 2004 to that in 2007?
Offer a very short reply. 0.85. What is the ratio of the Expenses (in $) of Custom duties in 2004 to that in 2007?
Offer a terse response. 85.99. What is the ratio of the Expenses (in $) in Interest Payments in 2004 to that in 2007?
Provide a succinct answer. 1.07. What is the ratio of the Expenses (in $) in Other expenses in 2004 to that in 2007?
Provide a succinct answer. 0.87. What is the ratio of the Expenses (in $) of Salary of employees in 2004 to that in 2008?
Your answer should be compact. 0.75. What is the ratio of the Expenses (in $) of Custom duties in 2004 to that in 2008?
Your answer should be compact. 2122.76. What is the ratio of the Expenses (in $) of Interest Payments in 2004 to that in 2008?
Give a very brief answer. 1.07. What is the ratio of the Expenses (in $) of Other expenses in 2004 to that in 2008?
Your answer should be compact. 0.79. What is the ratio of the Expenses (in $) in Salary of employees in 2004 to that in 2009?
Provide a succinct answer. 0.72. What is the ratio of the Expenses (in $) in Custom duties in 2004 to that in 2009?
Keep it short and to the point. 2198.31. What is the ratio of the Expenses (in $) in Other expenses in 2004 to that in 2009?
Provide a succinct answer. 0.72. What is the ratio of the Expenses (in $) of Salary of employees in 2004 to that in 2010?
Offer a very short reply. 0.73. What is the ratio of the Expenses (in $) of Custom duties in 2004 to that in 2010?
Ensure brevity in your answer.  2138.02. What is the ratio of the Expenses (in $) in Other expenses in 2004 to that in 2010?
Provide a short and direct response. 0.71. What is the ratio of the Expenses (in $) of Salary of employees in 2005 to that in 2006?
Provide a succinct answer. 0.81. What is the ratio of the Expenses (in $) in Interest Payments in 2005 to that in 2006?
Make the answer very short. 0.74. What is the ratio of the Expenses (in $) in Other expenses in 2005 to that in 2006?
Give a very brief answer. 0.9. What is the ratio of the Expenses (in $) of Salary of employees in 2005 to that in 2007?
Give a very brief answer. 0.84. What is the ratio of the Expenses (in $) of Custom duties in 2005 to that in 2007?
Make the answer very short. 23.13. What is the ratio of the Expenses (in $) of Interest Payments in 2005 to that in 2007?
Your response must be concise. 0.86. What is the ratio of the Expenses (in $) of Other expenses in 2005 to that in 2007?
Your answer should be very brief. 0.88. What is the ratio of the Expenses (in $) of Salary of employees in 2005 to that in 2008?
Ensure brevity in your answer.  0.75. What is the ratio of the Expenses (in $) of Custom duties in 2005 to that in 2008?
Provide a succinct answer. 571.03. What is the ratio of the Expenses (in $) of Interest Payments in 2005 to that in 2008?
Keep it short and to the point. 0.86. What is the ratio of the Expenses (in $) in Other expenses in 2005 to that in 2008?
Keep it short and to the point. 0.8. What is the ratio of the Expenses (in $) in Salary of employees in 2005 to that in 2009?
Provide a short and direct response. 0.71. What is the ratio of the Expenses (in $) of Custom duties in 2005 to that in 2009?
Offer a terse response. 591.35. What is the ratio of the Expenses (in $) of Interest Payments in 2005 to that in 2009?
Provide a succinct answer. 0.8. What is the ratio of the Expenses (in $) in Other expenses in 2005 to that in 2009?
Offer a terse response. 0.73. What is the ratio of the Expenses (in $) in Salary of employees in 2005 to that in 2010?
Your answer should be very brief. 0.72. What is the ratio of the Expenses (in $) in Custom duties in 2005 to that in 2010?
Ensure brevity in your answer.  575.13. What is the ratio of the Expenses (in $) in Interest Payments in 2005 to that in 2010?
Give a very brief answer. 0.8. What is the ratio of the Expenses (in $) of Other expenses in 2005 to that in 2010?
Provide a short and direct response. 0.72. What is the ratio of the Expenses (in $) in Salary of employees in 2006 to that in 2007?
Make the answer very short. 1.04. What is the ratio of the Expenses (in $) of Interest Payments in 2006 to that in 2007?
Your answer should be compact. 1.16. What is the ratio of the Expenses (in $) of Other expenses in 2006 to that in 2007?
Give a very brief answer. 0.97. What is the ratio of the Expenses (in $) in Salary of employees in 2006 to that in 2008?
Give a very brief answer. 0.92. What is the ratio of the Expenses (in $) of Interest Payments in 2006 to that in 2008?
Your response must be concise. 1.16. What is the ratio of the Expenses (in $) in Other expenses in 2006 to that in 2008?
Offer a very short reply. 0.88. What is the ratio of the Expenses (in $) in Salary of employees in 2006 to that in 2009?
Give a very brief answer. 0.88. What is the ratio of the Expenses (in $) in Interest Payments in 2006 to that in 2009?
Your response must be concise. 1.07. What is the ratio of the Expenses (in $) of Other expenses in 2006 to that in 2009?
Offer a terse response. 0.81. What is the ratio of the Expenses (in $) of Salary of employees in 2006 to that in 2010?
Your answer should be very brief. 0.89. What is the ratio of the Expenses (in $) of Interest Payments in 2006 to that in 2010?
Make the answer very short. 1.09. What is the ratio of the Expenses (in $) in Other expenses in 2006 to that in 2010?
Offer a terse response. 0.8. What is the ratio of the Expenses (in $) of Salary of employees in 2007 to that in 2008?
Ensure brevity in your answer.  0.89. What is the ratio of the Expenses (in $) of Custom duties in 2007 to that in 2008?
Offer a terse response. 24.69. What is the ratio of the Expenses (in $) in Other expenses in 2007 to that in 2008?
Your response must be concise. 0.91. What is the ratio of the Expenses (in $) of Salary of employees in 2007 to that in 2009?
Give a very brief answer. 0.85. What is the ratio of the Expenses (in $) in Custom duties in 2007 to that in 2009?
Your answer should be compact. 25.57. What is the ratio of the Expenses (in $) in Interest Payments in 2007 to that in 2009?
Provide a short and direct response. 0.92. What is the ratio of the Expenses (in $) in Other expenses in 2007 to that in 2009?
Provide a short and direct response. 0.83. What is the ratio of the Expenses (in $) of Salary of employees in 2007 to that in 2010?
Your answer should be very brief. 0.86. What is the ratio of the Expenses (in $) of Custom duties in 2007 to that in 2010?
Ensure brevity in your answer.  24.86. What is the ratio of the Expenses (in $) in Interest Payments in 2007 to that in 2010?
Make the answer very short. 0.93. What is the ratio of the Expenses (in $) of Other expenses in 2007 to that in 2010?
Provide a short and direct response. 0.82. What is the ratio of the Expenses (in $) in Salary of employees in 2008 to that in 2009?
Ensure brevity in your answer.  0.95. What is the ratio of the Expenses (in $) of Custom duties in 2008 to that in 2009?
Make the answer very short. 1.04. What is the ratio of the Expenses (in $) in Interest Payments in 2008 to that in 2009?
Your answer should be compact. 0.93. What is the ratio of the Expenses (in $) in Other expenses in 2008 to that in 2009?
Your answer should be compact. 0.91. What is the ratio of the Expenses (in $) of Salary of employees in 2008 to that in 2010?
Your answer should be compact. 0.97. What is the ratio of the Expenses (in $) of Interest Payments in 2008 to that in 2010?
Make the answer very short. 0.94. What is the ratio of the Expenses (in $) of Other expenses in 2008 to that in 2010?
Ensure brevity in your answer.  0.9. What is the ratio of the Expenses (in $) of Custom duties in 2009 to that in 2010?
Offer a terse response. 0.97. What is the ratio of the Expenses (in $) of Interest Payments in 2009 to that in 2010?
Your response must be concise. 1.01. What is the difference between the highest and the second highest Expenses (in $) of Salary of employees?
Offer a very short reply. 4.65e+07. What is the difference between the highest and the second highest Expenses (in $) of Custom duties?
Your answer should be very brief. 6.98e+07. What is the difference between the highest and the second highest Expenses (in $) of Interest Payments?
Provide a short and direct response. 6.08e+07. What is the difference between the highest and the second highest Expenses (in $) of Other expenses?
Keep it short and to the point. 2.73e+08. What is the difference between the highest and the lowest Expenses (in $) of Salary of employees?
Ensure brevity in your answer.  9.97e+08. What is the difference between the highest and the lowest Expenses (in $) in Custom duties?
Offer a very short reply. 1.31e+08. What is the difference between the highest and the lowest Expenses (in $) in Interest Payments?
Ensure brevity in your answer.  3.06e+08. What is the difference between the highest and the lowest Expenses (in $) of Other expenses?
Give a very brief answer. 8.03e+09. 